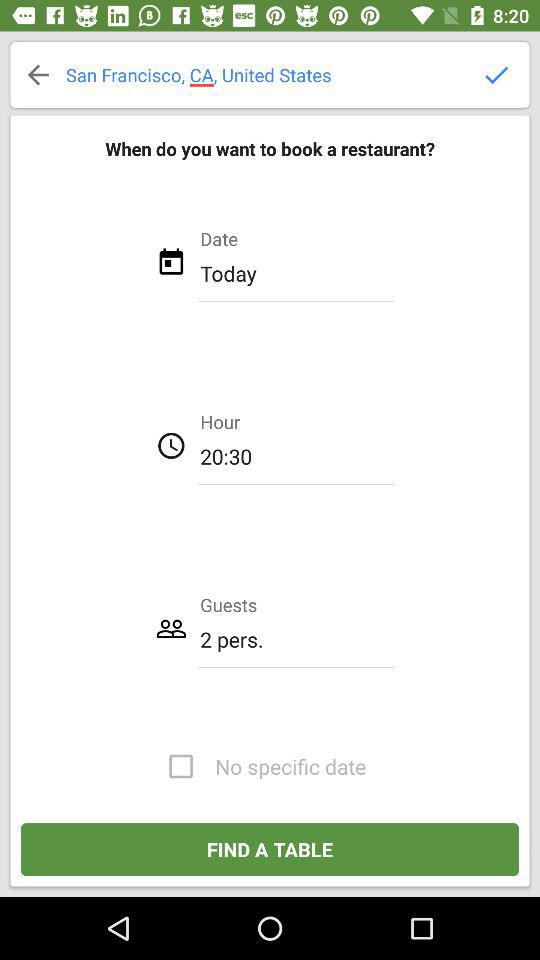What location is entered? The entered location is San Francisco, CA, United States. 